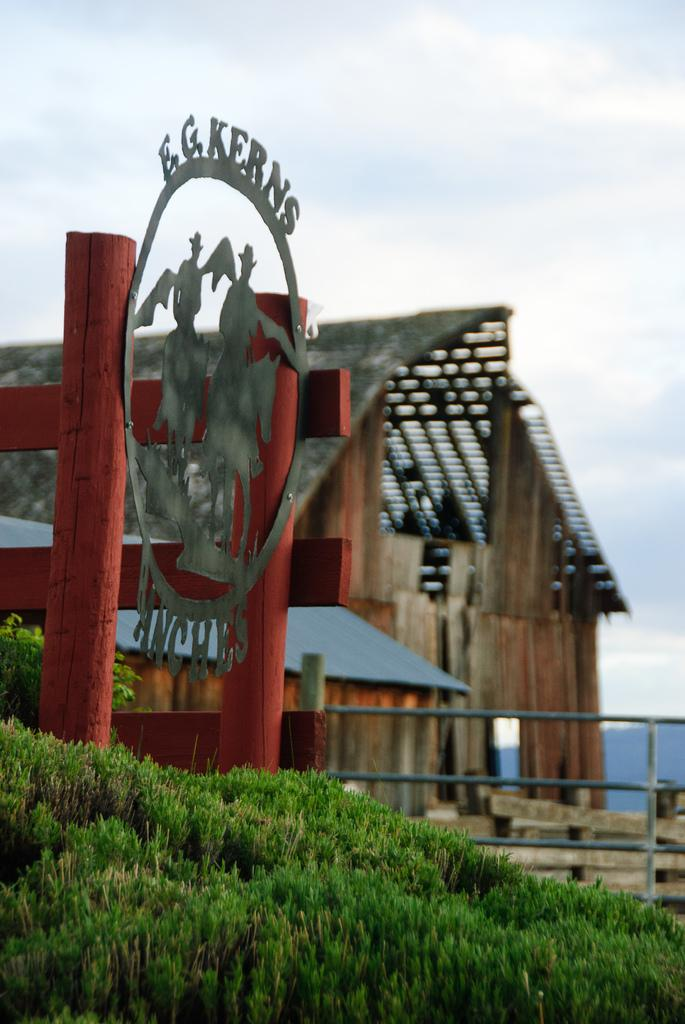<image>
Present a compact description of the photo's key features. Silhouettes of cowboys on horses are in the center of a metal E.G. Kerns Ranches sign. 